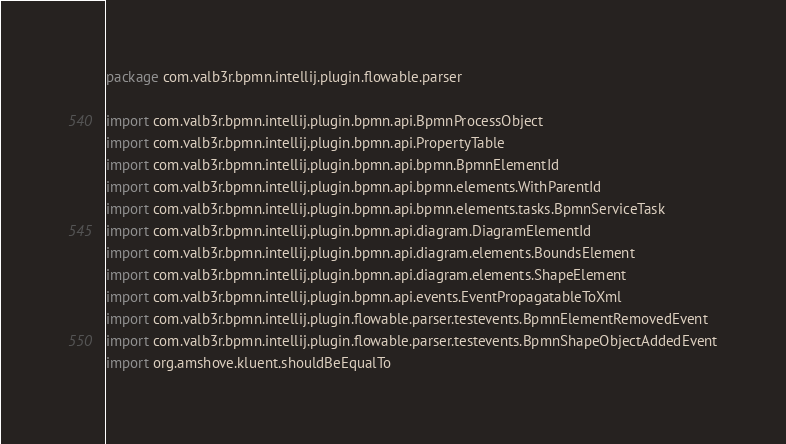<code> <loc_0><loc_0><loc_500><loc_500><_Kotlin_>package com.valb3r.bpmn.intellij.plugin.flowable.parser

import com.valb3r.bpmn.intellij.plugin.bpmn.api.BpmnProcessObject
import com.valb3r.bpmn.intellij.plugin.bpmn.api.PropertyTable
import com.valb3r.bpmn.intellij.plugin.bpmn.api.bpmn.BpmnElementId
import com.valb3r.bpmn.intellij.plugin.bpmn.api.bpmn.elements.WithParentId
import com.valb3r.bpmn.intellij.plugin.bpmn.api.bpmn.elements.tasks.BpmnServiceTask
import com.valb3r.bpmn.intellij.plugin.bpmn.api.diagram.DiagramElementId
import com.valb3r.bpmn.intellij.plugin.bpmn.api.diagram.elements.BoundsElement
import com.valb3r.bpmn.intellij.plugin.bpmn.api.diagram.elements.ShapeElement
import com.valb3r.bpmn.intellij.plugin.bpmn.api.events.EventPropagatableToXml
import com.valb3r.bpmn.intellij.plugin.flowable.parser.testevents.BpmnElementRemovedEvent
import com.valb3r.bpmn.intellij.plugin.flowable.parser.testevents.BpmnShapeObjectAddedEvent
import org.amshove.kluent.shouldBeEqualTo</code> 